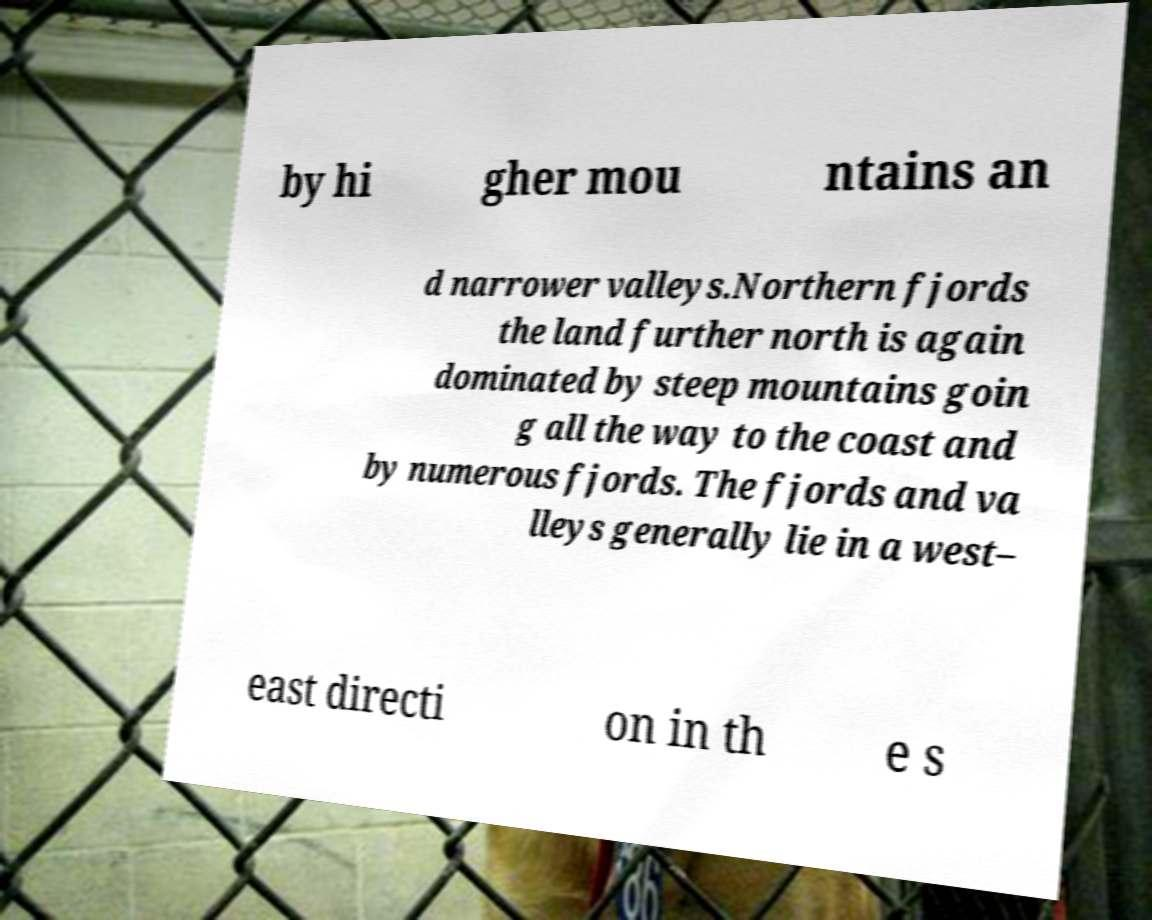What messages or text are displayed in this image? I need them in a readable, typed format. by hi gher mou ntains an d narrower valleys.Northern fjords the land further north is again dominated by steep mountains goin g all the way to the coast and by numerous fjords. The fjords and va lleys generally lie in a west– east directi on in th e s 